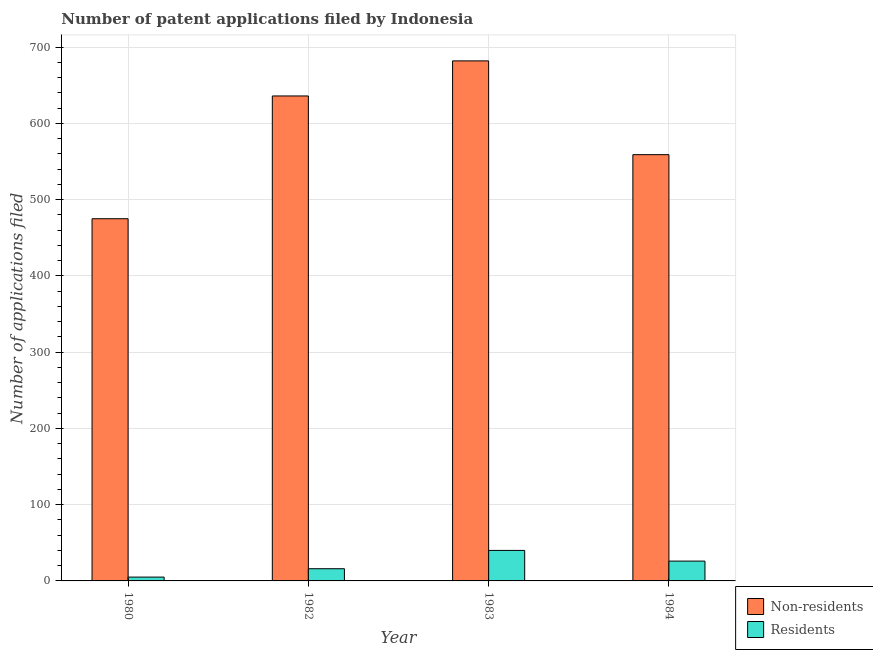Are the number of bars on each tick of the X-axis equal?
Offer a very short reply. Yes. How many bars are there on the 4th tick from the left?
Offer a terse response. 2. How many bars are there on the 3rd tick from the right?
Ensure brevity in your answer.  2. What is the number of patent applications by residents in 1980?
Your answer should be very brief. 5. Across all years, what is the maximum number of patent applications by residents?
Ensure brevity in your answer.  40. Across all years, what is the minimum number of patent applications by residents?
Your response must be concise. 5. In which year was the number of patent applications by non residents minimum?
Ensure brevity in your answer.  1980. What is the total number of patent applications by residents in the graph?
Ensure brevity in your answer.  87. What is the difference between the number of patent applications by non residents in 1980 and that in 1984?
Offer a terse response. -84. What is the difference between the number of patent applications by non residents in 1980 and the number of patent applications by residents in 1983?
Provide a short and direct response. -207. What is the average number of patent applications by non residents per year?
Offer a very short reply. 588. What is the ratio of the number of patent applications by non residents in 1982 to that in 1984?
Your response must be concise. 1.14. Is the number of patent applications by residents in 1983 less than that in 1984?
Provide a succinct answer. No. What is the difference between the highest and the lowest number of patent applications by residents?
Your answer should be very brief. 35. Is the sum of the number of patent applications by non residents in 1980 and 1982 greater than the maximum number of patent applications by residents across all years?
Make the answer very short. Yes. What does the 2nd bar from the left in 1984 represents?
Provide a short and direct response. Residents. What does the 2nd bar from the right in 1983 represents?
Your answer should be very brief. Non-residents. Are all the bars in the graph horizontal?
Your response must be concise. No. How many years are there in the graph?
Your answer should be very brief. 4. Does the graph contain any zero values?
Make the answer very short. No. Does the graph contain grids?
Ensure brevity in your answer.  Yes. What is the title of the graph?
Provide a succinct answer. Number of patent applications filed by Indonesia. Does "Nitrous oxide" appear as one of the legend labels in the graph?
Provide a succinct answer. No. What is the label or title of the Y-axis?
Offer a very short reply. Number of applications filed. What is the Number of applications filed in Non-residents in 1980?
Your answer should be compact. 475. What is the Number of applications filed in Non-residents in 1982?
Make the answer very short. 636. What is the Number of applications filed of Non-residents in 1983?
Your answer should be compact. 682. What is the Number of applications filed of Residents in 1983?
Provide a short and direct response. 40. What is the Number of applications filed in Non-residents in 1984?
Your answer should be very brief. 559. What is the Number of applications filed in Residents in 1984?
Ensure brevity in your answer.  26. Across all years, what is the maximum Number of applications filed in Non-residents?
Make the answer very short. 682. Across all years, what is the maximum Number of applications filed in Residents?
Provide a short and direct response. 40. Across all years, what is the minimum Number of applications filed in Non-residents?
Your answer should be compact. 475. Across all years, what is the minimum Number of applications filed in Residents?
Provide a short and direct response. 5. What is the total Number of applications filed of Non-residents in the graph?
Provide a succinct answer. 2352. What is the difference between the Number of applications filed in Non-residents in 1980 and that in 1982?
Provide a succinct answer. -161. What is the difference between the Number of applications filed of Residents in 1980 and that in 1982?
Your answer should be very brief. -11. What is the difference between the Number of applications filed of Non-residents in 1980 and that in 1983?
Give a very brief answer. -207. What is the difference between the Number of applications filed of Residents in 1980 and that in 1983?
Provide a succinct answer. -35. What is the difference between the Number of applications filed of Non-residents in 1980 and that in 1984?
Keep it short and to the point. -84. What is the difference between the Number of applications filed in Non-residents in 1982 and that in 1983?
Ensure brevity in your answer.  -46. What is the difference between the Number of applications filed in Residents in 1982 and that in 1983?
Provide a short and direct response. -24. What is the difference between the Number of applications filed of Residents in 1982 and that in 1984?
Your answer should be compact. -10. What is the difference between the Number of applications filed in Non-residents in 1983 and that in 1984?
Your answer should be very brief. 123. What is the difference between the Number of applications filed in Non-residents in 1980 and the Number of applications filed in Residents in 1982?
Give a very brief answer. 459. What is the difference between the Number of applications filed of Non-residents in 1980 and the Number of applications filed of Residents in 1983?
Your answer should be compact. 435. What is the difference between the Number of applications filed of Non-residents in 1980 and the Number of applications filed of Residents in 1984?
Keep it short and to the point. 449. What is the difference between the Number of applications filed in Non-residents in 1982 and the Number of applications filed in Residents in 1983?
Give a very brief answer. 596. What is the difference between the Number of applications filed in Non-residents in 1982 and the Number of applications filed in Residents in 1984?
Your response must be concise. 610. What is the difference between the Number of applications filed of Non-residents in 1983 and the Number of applications filed of Residents in 1984?
Offer a terse response. 656. What is the average Number of applications filed in Non-residents per year?
Your answer should be compact. 588. What is the average Number of applications filed of Residents per year?
Keep it short and to the point. 21.75. In the year 1980, what is the difference between the Number of applications filed in Non-residents and Number of applications filed in Residents?
Your answer should be very brief. 470. In the year 1982, what is the difference between the Number of applications filed of Non-residents and Number of applications filed of Residents?
Provide a short and direct response. 620. In the year 1983, what is the difference between the Number of applications filed of Non-residents and Number of applications filed of Residents?
Keep it short and to the point. 642. In the year 1984, what is the difference between the Number of applications filed in Non-residents and Number of applications filed in Residents?
Offer a terse response. 533. What is the ratio of the Number of applications filed in Non-residents in 1980 to that in 1982?
Your response must be concise. 0.75. What is the ratio of the Number of applications filed in Residents in 1980 to that in 1982?
Ensure brevity in your answer.  0.31. What is the ratio of the Number of applications filed in Non-residents in 1980 to that in 1983?
Give a very brief answer. 0.7. What is the ratio of the Number of applications filed in Non-residents in 1980 to that in 1984?
Keep it short and to the point. 0.85. What is the ratio of the Number of applications filed of Residents in 1980 to that in 1984?
Keep it short and to the point. 0.19. What is the ratio of the Number of applications filed in Non-residents in 1982 to that in 1983?
Provide a succinct answer. 0.93. What is the ratio of the Number of applications filed of Residents in 1982 to that in 1983?
Your response must be concise. 0.4. What is the ratio of the Number of applications filed of Non-residents in 1982 to that in 1984?
Ensure brevity in your answer.  1.14. What is the ratio of the Number of applications filed of Residents in 1982 to that in 1984?
Offer a very short reply. 0.62. What is the ratio of the Number of applications filed of Non-residents in 1983 to that in 1984?
Keep it short and to the point. 1.22. What is the ratio of the Number of applications filed in Residents in 1983 to that in 1984?
Keep it short and to the point. 1.54. What is the difference between the highest and the second highest Number of applications filed of Non-residents?
Provide a short and direct response. 46. What is the difference between the highest and the lowest Number of applications filed in Non-residents?
Ensure brevity in your answer.  207. What is the difference between the highest and the lowest Number of applications filed of Residents?
Provide a short and direct response. 35. 